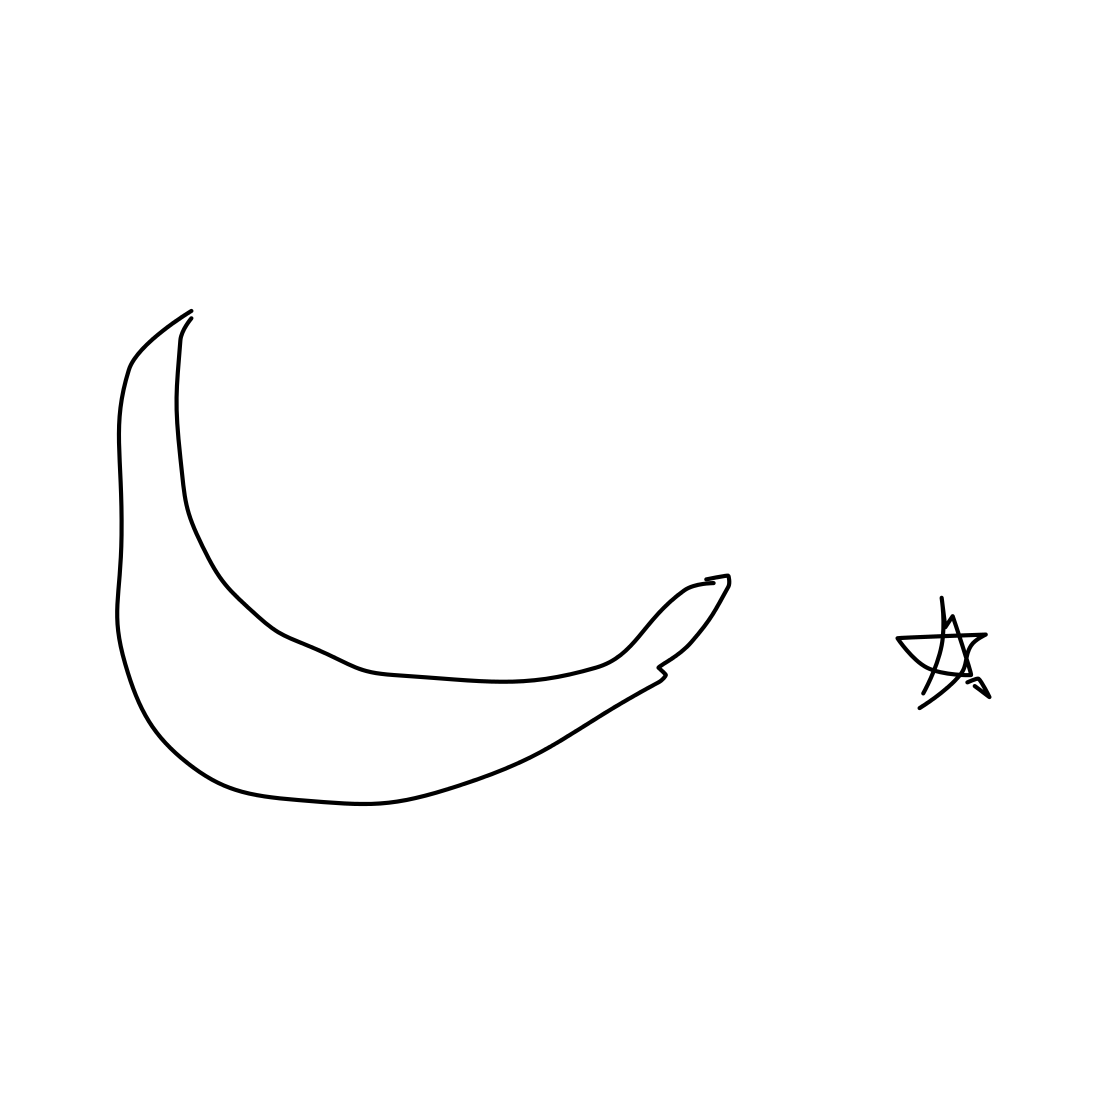Each image is a human drawn sketch of a object. Identify the main object in the image. The main object in the image is a banana. It is identifiable by its elongated, curved shape and the segmented lines that suggest the familiar form of a banana's peel. The drawing is stylized but still retains the essential characteristics that one would associate with a banana. The size of the object in relation to the star suggests it is the primary subject of the drawing. 